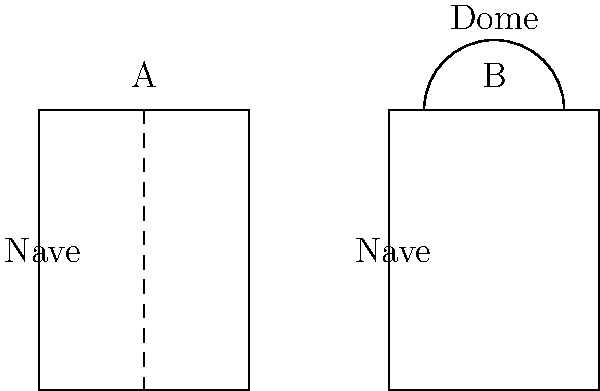Compare the structural elements of Church A and Church B, both renovated by Francesco Focardi Mazzocchi. What is the primary architectural difference between these two churches, and how might this affect the interior space? To answer this question, let's analyze the structural elements of both churches step-by-step:

1. Church A:
   - Rectangular shape
   - Single nave structure
   - No visible dome or additional elements

2. Church B:
   - Rectangular base similar to Church A
   - Addition of a dome on top

3. Primary architectural difference:
   The main difference is the presence of a dome in Church B, which is absent in Church A.

4. Effect on interior space:
   a) Church A (without dome):
      - Likely has a more uniform height throughout
      - May feel more enclosed and intimate
      - Possible flat or slightly vaulted ceiling

   b) Church B (with dome):
      - Creates a central focal point
      - Increases the height and volume of the interior space
      - Allows for more natural light if the dome has windows
      - May create a sense of vertical expansion and grandeur

5. Francesco Focardi Mazzocchi's approach:
   The addition of the dome in Church B suggests that Mazzocchi may have aimed to create a more monumental and spatially diverse interior in this renovation, while potentially preserving a simpler, more traditional layout in Church A.
Answer: The primary difference is the dome in Church B, which likely creates a more expansive and light-filled interior compared to the uniform, intimate space of Church A. 